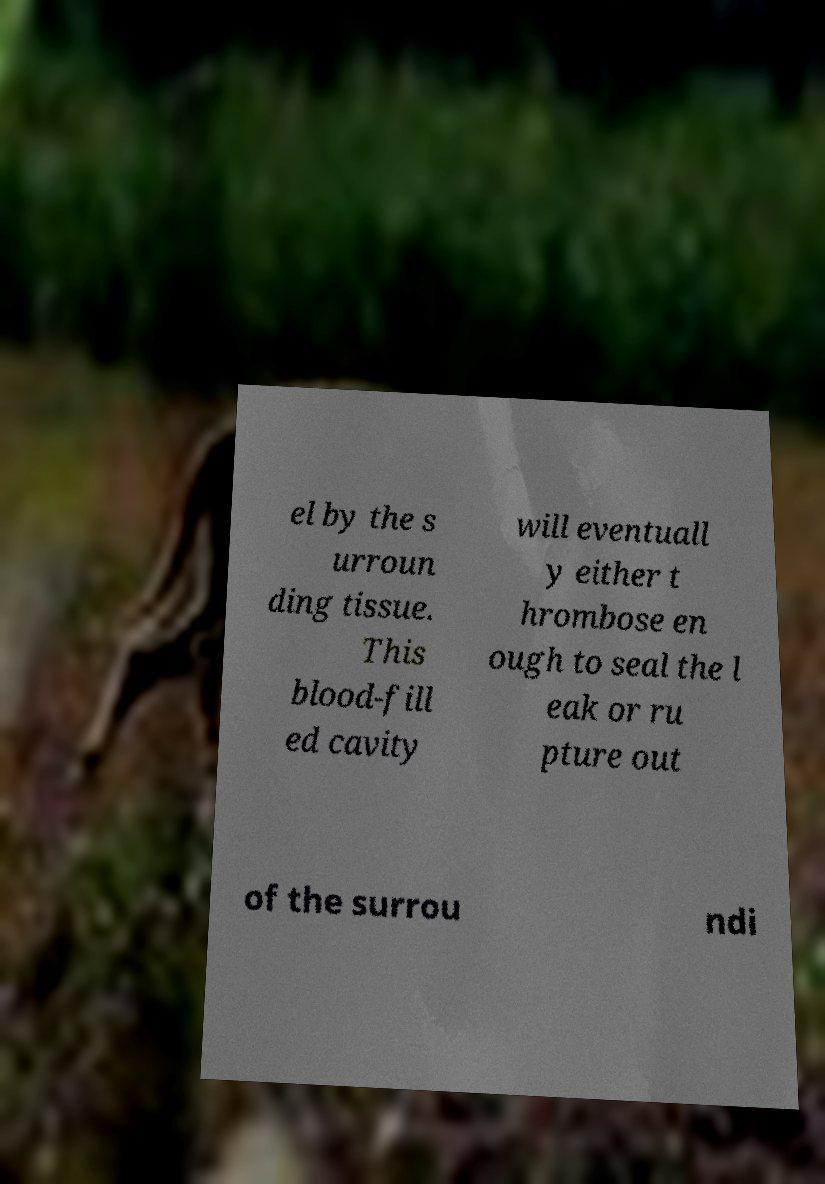I need the written content from this picture converted into text. Can you do that? el by the s urroun ding tissue. This blood-fill ed cavity will eventuall y either t hrombose en ough to seal the l eak or ru pture out of the surrou ndi 